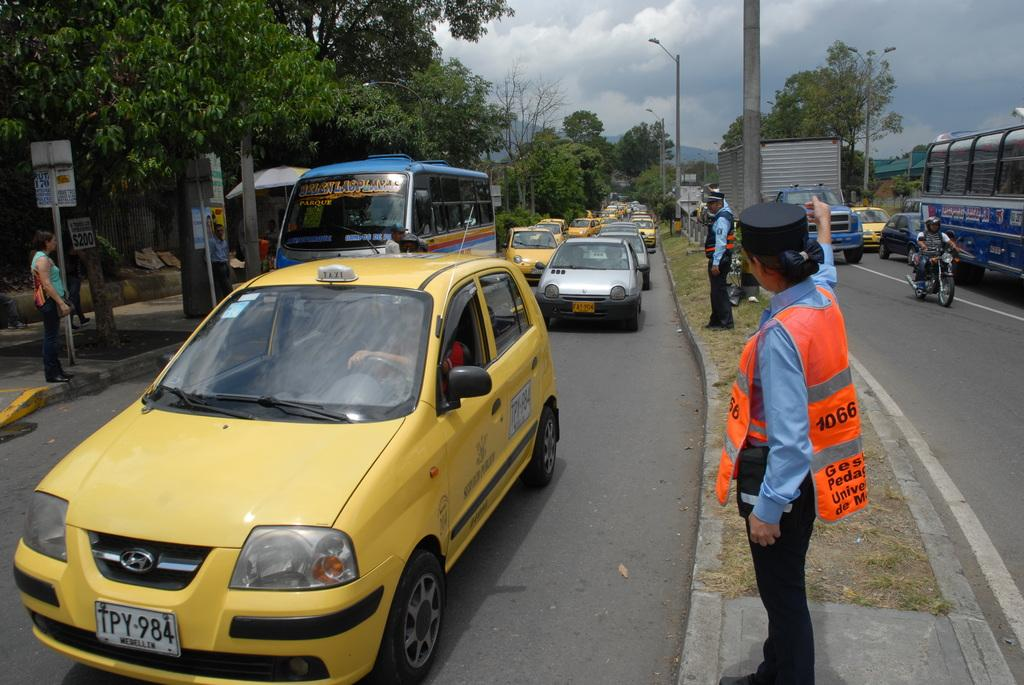<image>
Present a compact description of the photo's key features. A yellow car with the license plate TPY-984 drives down a street. 